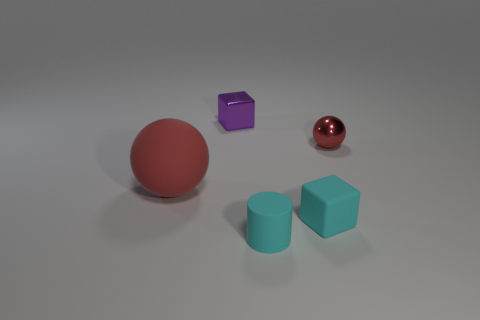Can you describe the lighting in the scene and how it affects the appearance of the objects? The image is softly lit from above, creating gentle shadows that ground the objects. The lighting accentuates the sheen on the metallic sphere, gives the matte sphere a diffuse reflection, and allows the true colors of the cubes to be visible without harsh reflections, highlighting their textures and colors in a pleasing, natural way. 